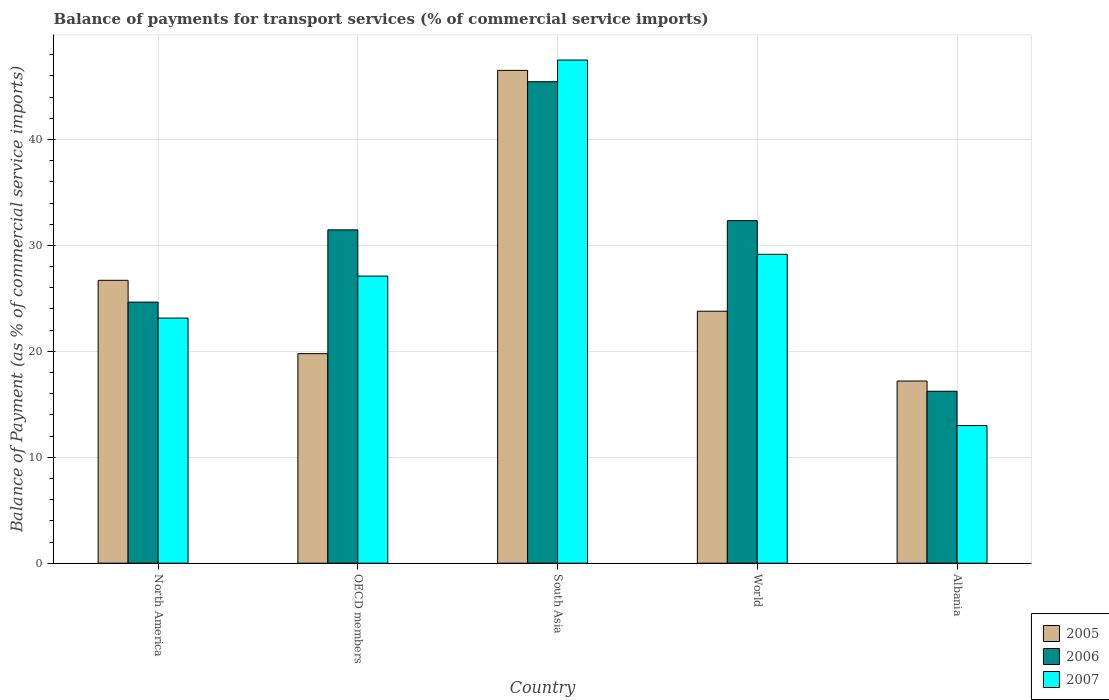How many different coloured bars are there?
Offer a terse response. 3. How many groups of bars are there?
Your response must be concise. 5. Are the number of bars per tick equal to the number of legend labels?
Make the answer very short. Yes. How many bars are there on the 1st tick from the left?
Keep it short and to the point. 3. In how many cases, is the number of bars for a given country not equal to the number of legend labels?
Your response must be concise. 0. What is the balance of payments for transport services in 2007 in OECD members?
Offer a very short reply. 27.11. Across all countries, what is the maximum balance of payments for transport services in 2007?
Your answer should be very brief. 47.5. Across all countries, what is the minimum balance of payments for transport services in 2006?
Provide a succinct answer. 16.23. In which country was the balance of payments for transport services in 2005 maximum?
Ensure brevity in your answer.  South Asia. In which country was the balance of payments for transport services in 2007 minimum?
Give a very brief answer. Albania. What is the total balance of payments for transport services in 2006 in the graph?
Give a very brief answer. 150.14. What is the difference between the balance of payments for transport services in 2007 in OECD members and that in South Asia?
Offer a very short reply. -20.39. What is the difference between the balance of payments for transport services in 2005 in OECD members and the balance of payments for transport services in 2007 in World?
Your answer should be compact. -9.38. What is the average balance of payments for transport services in 2007 per country?
Offer a very short reply. 27.98. What is the difference between the balance of payments for transport services of/in 2007 and balance of payments for transport services of/in 2005 in World?
Provide a short and direct response. 5.37. What is the ratio of the balance of payments for transport services in 2005 in Albania to that in North America?
Your answer should be compact. 0.64. Is the balance of payments for transport services in 2007 in OECD members less than that in South Asia?
Your response must be concise. Yes. Is the difference between the balance of payments for transport services in 2007 in North America and OECD members greater than the difference between the balance of payments for transport services in 2005 in North America and OECD members?
Make the answer very short. No. What is the difference between the highest and the second highest balance of payments for transport services in 2005?
Give a very brief answer. -19.82. What is the difference between the highest and the lowest balance of payments for transport services in 2005?
Offer a terse response. 29.33. In how many countries, is the balance of payments for transport services in 2005 greater than the average balance of payments for transport services in 2005 taken over all countries?
Offer a terse response. 1. What does the 1st bar from the right in OECD members represents?
Make the answer very short. 2007. Are all the bars in the graph horizontal?
Your answer should be very brief. No. What is the difference between two consecutive major ticks on the Y-axis?
Offer a very short reply. 10. Are the values on the major ticks of Y-axis written in scientific E-notation?
Keep it short and to the point. No. Does the graph contain any zero values?
Give a very brief answer. No. Where does the legend appear in the graph?
Make the answer very short. Bottom right. How are the legend labels stacked?
Your response must be concise. Vertical. What is the title of the graph?
Give a very brief answer. Balance of payments for transport services (% of commercial service imports). Does "1965" appear as one of the legend labels in the graph?
Provide a succinct answer. No. What is the label or title of the Y-axis?
Offer a very short reply. Balance of Payment (as % of commercial service imports). What is the Balance of Payment (as % of commercial service imports) of 2005 in North America?
Ensure brevity in your answer.  26.71. What is the Balance of Payment (as % of commercial service imports) in 2006 in North America?
Give a very brief answer. 24.65. What is the Balance of Payment (as % of commercial service imports) of 2007 in North America?
Your answer should be very brief. 23.14. What is the Balance of Payment (as % of commercial service imports) in 2005 in OECD members?
Provide a short and direct response. 19.78. What is the Balance of Payment (as % of commercial service imports) of 2006 in OECD members?
Offer a very short reply. 31.47. What is the Balance of Payment (as % of commercial service imports) in 2007 in OECD members?
Offer a very short reply. 27.11. What is the Balance of Payment (as % of commercial service imports) in 2005 in South Asia?
Keep it short and to the point. 46.53. What is the Balance of Payment (as % of commercial service imports) of 2006 in South Asia?
Offer a terse response. 45.46. What is the Balance of Payment (as % of commercial service imports) of 2007 in South Asia?
Offer a very short reply. 47.5. What is the Balance of Payment (as % of commercial service imports) in 2005 in World?
Make the answer very short. 23.79. What is the Balance of Payment (as % of commercial service imports) of 2006 in World?
Offer a terse response. 32.34. What is the Balance of Payment (as % of commercial service imports) in 2007 in World?
Give a very brief answer. 29.16. What is the Balance of Payment (as % of commercial service imports) in 2005 in Albania?
Offer a very short reply. 17.2. What is the Balance of Payment (as % of commercial service imports) of 2006 in Albania?
Your answer should be compact. 16.23. What is the Balance of Payment (as % of commercial service imports) in 2007 in Albania?
Your answer should be very brief. 12.99. Across all countries, what is the maximum Balance of Payment (as % of commercial service imports) in 2005?
Your answer should be compact. 46.53. Across all countries, what is the maximum Balance of Payment (as % of commercial service imports) in 2006?
Keep it short and to the point. 45.46. Across all countries, what is the maximum Balance of Payment (as % of commercial service imports) of 2007?
Give a very brief answer. 47.5. Across all countries, what is the minimum Balance of Payment (as % of commercial service imports) in 2005?
Provide a succinct answer. 17.2. Across all countries, what is the minimum Balance of Payment (as % of commercial service imports) in 2006?
Make the answer very short. 16.23. Across all countries, what is the minimum Balance of Payment (as % of commercial service imports) of 2007?
Your response must be concise. 12.99. What is the total Balance of Payment (as % of commercial service imports) in 2005 in the graph?
Provide a succinct answer. 134. What is the total Balance of Payment (as % of commercial service imports) of 2006 in the graph?
Provide a short and direct response. 150.14. What is the total Balance of Payment (as % of commercial service imports) of 2007 in the graph?
Your answer should be very brief. 139.9. What is the difference between the Balance of Payment (as % of commercial service imports) of 2005 in North America and that in OECD members?
Your answer should be very brief. 6.93. What is the difference between the Balance of Payment (as % of commercial service imports) of 2006 in North America and that in OECD members?
Offer a very short reply. -6.82. What is the difference between the Balance of Payment (as % of commercial service imports) of 2007 in North America and that in OECD members?
Ensure brevity in your answer.  -3.97. What is the difference between the Balance of Payment (as % of commercial service imports) of 2005 in North America and that in South Asia?
Make the answer very short. -19.82. What is the difference between the Balance of Payment (as % of commercial service imports) of 2006 in North America and that in South Asia?
Provide a succinct answer. -20.81. What is the difference between the Balance of Payment (as % of commercial service imports) in 2007 in North America and that in South Asia?
Give a very brief answer. -24.36. What is the difference between the Balance of Payment (as % of commercial service imports) of 2005 in North America and that in World?
Provide a short and direct response. 2.92. What is the difference between the Balance of Payment (as % of commercial service imports) of 2006 in North America and that in World?
Offer a terse response. -7.69. What is the difference between the Balance of Payment (as % of commercial service imports) in 2007 in North America and that in World?
Offer a terse response. -6.02. What is the difference between the Balance of Payment (as % of commercial service imports) in 2005 in North America and that in Albania?
Keep it short and to the point. 9.51. What is the difference between the Balance of Payment (as % of commercial service imports) in 2006 in North America and that in Albania?
Ensure brevity in your answer.  8.41. What is the difference between the Balance of Payment (as % of commercial service imports) in 2007 in North America and that in Albania?
Keep it short and to the point. 10.15. What is the difference between the Balance of Payment (as % of commercial service imports) in 2005 in OECD members and that in South Asia?
Provide a succinct answer. -26.74. What is the difference between the Balance of Payment (as % of commercial service imports) of 2006 in OECD members and that in South Asia?
Provide a succinct answer. -13.99. What is the difference between the Balance of Payment (as % of commercial service imports) in 2007 in OECD members and that in South Asia?
Ensure brevity in your answer.  -20.39. What is the difference between the Balance of Payment (as % of commercial service imports) of 2005 in OECD members and that in World?
Offer a very short reply. -4.01. What is the difference between the Balance of Payment (as % of commercial service imports) of 2006 in OECD members and that in World?
Ensure brevity in your answer.  -0.87. What is the difference between the Balance of Payment (as % of commercial service imports) of 2007 in OECD members and that in World?
Your response must be concise. -2.05. What is the difference between the Balance of Payment (as % of commercial service imports) of 2005 in OECD members and that in Albania?
Offer a very short reply. 2.58. What is the difference between the Balance of Payment (as % of commercial service imports) of 2006 in OECD members and that in Albania?
Provide a succinct answer. 15.24. What is the difference between the Balance of Payment (as % of commercial service imports) of 2007 in OECD members and that in Albania?
Your answer should be compact. 14.11. What is the difference between the Balance of Payment (as % of commercial service imports) of 2005 in South Asia and that in World?
Offer a very short reply. 22.74. What is the difference between the Balance of Payment (as % of commercial service imports) in 2006 in South Asia and that in World?
Keep it short and to the point. 13.12. What is the difference between the Balance of Payment (as % of commercial service imports) in 2007 in South Asia and that in World?
Your answer should be compact. 18.34. What is the difference between the Balance of Payment (as % of commercial service imports) of 2005 in South Asia and that in Albania?
Your answer should be very brief. 29.33. What is the difference between the Balance of Payment (as % of commercial service imports) of 2006 in South Asia and that in Albania?
Keep it short and to the point. 29.22. What is the difference between the Balance of Payment (as % of commercial service imports) of 2007 in South Asia and that in Albania?
Offer a very short reply. 34.51. What is the difference between the Balance of Payment (as % of commercial service imports) in 2005 in World and that in Albania?
Make the answer very short. 6.59. What is the difference between the Balance of Payment (as % of commercial service imports) of 2006 in World and that in Albania?
Your response must be concise. 16.11. What is the difference between the Balance of Payment (as % of commercial service imports) in 2007 in World and that in Albania?
Provide a short and direct response. 16.17. What is the difference between the Balance of Payment (as % of commercial service imports) in 2005 in North America and the Balance of Payment (as % of commercial service imports) in 2006 in OECD members?
Your answer should be compact. -4.76. What is the difference between the Balance of Payment (as % of commercial service imports) of 2005 in North America and the Balance of Payment (as % of commercial service imports) of 2007 in OECD members?
Your response must be concise. -0.4. What is the difference between the Balance of Payment (as % of commercial service imports) of 2006 in North America and the Balance of Payment (as % of commercial service imports) of 2007 in OECD members?
Your response must be concise. -2.46. What is the difference between the Balance of Payment (as % of commercial service imports) of 2005 in North America and the Balance of Payment (as % of commercial service imports) of 2006 in South Asia?
Offer a very short reply. -18.75. What is the difference between the Balance of Payment (as % of commercial service imports) of 2005 in North America and the Balance of Payment (as % of commercial service imports) of 2007 in South Asia?
Offer a terse response. -20.79. What is the difference between the Balance of Payment (as % of commercial service imports) in 2006 in North America and the Balance of Payment (as % of commercial service imports) in 2007 in South Asia?
Offer a terse response. -22.85. What is the difference between the Balance of Payment (as % of commercial service imports) in 2005 in North America and the Balance of Payment (as % of commercial service imports) in 2006 in World?
Keep it short and to the point. -5.63. What is the difference between the Balance of Payment (as % of commercial service imports) of 2005 in North America and the Balance of Payment (as % of commercial service imports) of 2007 in World?
Your response must be concise. -2.45. What is the difference between the Balance of Payment (as % of commercial service imports) in 2006 in North America and the Balance of Payment (as % of commercial service imports) in 2007 in World?
Offer a very short reply. -4.51. What is the difference between the Balance of Payment (as % of commercial service imports) in 2005 in North America and the Balance of Payment (as % of commercial service imports) in 2006 in Albania?
Provide a short and direct response. 10.48. What is the difference between the Balance of Payment (as % of commercial service imports) in 2005 in North America and the Balance of Payment (as % of commercial service imports) in 2007 in Albania?
Your answer should be compact. 13.71. What is the difference between the Balance of Payment (as % of commercial service imports) of 2006 in North America and the Balance of Payment (as % of commercial service imports) of 2007 in Albania?
Give a very brief answer. 11.65. What is the difference between the Balance of Payment (as % of commercial service imports) in 2005 in OECD members and the Balance of Payment (as % of commercial service imports) in 2006 in South Asia?
Make the answer very short. -25.67. What is the difference between the Balance of Payment (as % of commercial service imports) in 2005 in OECD members and the Balance of Payment (as % of commercial service imports) in 2007 in South Asia?
Ensure brevity in your answer.  -27.72. What is the difference between the Balance of Payment (as % of commercial service imports) of 2006 in OECD members and the Balance of Payment (as % of commercial service imports) of 2007 in South Asia?
Provide a succinct answer. -16.03. What is the difference between the Balance of Payment (as % of commercial service imports) in 2005 in OECD members and the Balance of Payment (as % of commercial service imports) in 2006 in World?
Your answer should be compact. -12.56. What is the difference between the Balance of Payment (as % of commercial service imports) in 2005 in OECD members and the Balance of Payment (as % of commercial service imports) in 2007 in World?
Give a very brief answer. -9.38. What is the difference between the Balance of Payment (as % of commercial service imports) of 2006 in OECD members and the Balance of Payment (as % of commercial service imports) of 2007 in World?
Keep it short and to the point. 2.31. What is the difference between the Balance of Payment (as % of commercial service imports) of 2005 in OECD members and the Balance of Payment (as % of commercial service imports) of 2006 in Albania?
Ensure brevity in your answer.  3.55. What is the difference between the Balance of Payment (as % of commercial service imports) in 2005 in OECD members and the Balance of Payment (as % of commercial service imports) in 2007 in Albania?
Ensure brevity in your answer.  6.79. What is the difference between the Balance of Payment (as % of commercial service imports) in 2006 in OECD members and the Balance of Payment (as % of commercial service imports) in 2007 in Albania?
Your answer should be compact. 18.48. What is the difference between the Balance of Payment (as % of commercial service imports) of 2005 in South Asia and the Balance of Payment (as % of commercial service imports) of 2006 in World?
Provide a succinct answer. 14.19. What is the difference between the Balance of Payment (as % of commercial service imports) in 2005 in South Asia and the Balance of Payment (as % of commercial service imports) in 2007 in World?
Your response must be concise. 17.36. What is the difference between the Balance of Payment (as % of commercial service imports) of 2006 in South Asia and the Balance of Payment (as % of commercial service imports) of 2007 in World?
Give a very brief answer. 16.29. What is the difference between the Balance of Payment (as % of commercial service imports) of 2005 in South Asia and the Balance of Payment (as % of commercial service imports) of 2006 in Albania?
Provide a succinct answer. 30.29. What is the difference between the Balance of Payment (as % of commercial service imports) in 2005 in South Asia and the Balance of Payment (as % of commercial service imports) in 2007 in Albania?
Keep it short and to the point. 33.53. What is the difference between the Balance of Payment (as % of commercial service imports) in 2006 in South Asia and the Balance of Payment (as % of commercial service imports) in 2007 in Albania?
Your answer should be compact. 32.46. What is the difference between the Balance of Payment (as % of commercial service imports) in 2005 in World and the Balance of Payment (as % of commercial service imports) in 2006 in Albania?
Your answer should be very brief. 7.56. What is the difference between the Balance of Payment (as % of commercial service imports) in 2005 in World and the Balance of Payment (as % of commercial service imports) in 2007 in Albania?
Offer a very short reply. 10.8. What is the difference between the Balance of Payment (as % of commercial service imports) of 2006 in World and the Balance of Payment (as % of commercial service imports) of 2007 in Albania?
Your answer should be compact. 19.35. What is the average Balance of Payment (as % of commercial service imports) of 2005 per country?
Offer a terse response. 26.8. What is the average Balance of Payment (as % of commercial service imports) of 2006 per country?
Provide a short and direct response. 30.03. What is the average Balance of Payment (as % of commercial service imports) in 2007 per country?
Your answer should be very brief. 27.98. What is the difference between the Balance of Payment (as % of commercial service imports) of 2005 and Balance of Payment (as % of commercial service imports) of 2006 in North America?
Provide a succinct answer. 2.06. What is the difference between the Balance of Payment (as % of commercial service imports) of 2005 and Balance of Payment (as % of commercial service imports) of 2007 in North America?
Offer a very short reply. 3.57. What is the difference between the Balance of Payment (as % of commercial service imports) in 2006 and Balance of Payment (as % of commercial service imports) in 2007 in North America?
Keep it short and to the point. 1.51. What is the difference between the Balance of Payment (as % of commercial service imports) of 2005 and Balance of Payment (as % of commercial service imports) of 2006 in OECD members?
Provide a short and direct response. -11.69. What is the difference between the Balance of Payment (as % of commercial service imports) of 2005 and Balance of Payment (as % of commercial service imports) of 2007 in OECD members?
Offer a very short reply. -7.33. What is the difference between the Balance of Payment (as % of commercial service imports) in 2006 and Balance of Payment (as % of commercial service imports) in 2007 in OECD members?
Provide a short and direct response. 4.36. What is the difference between the Balance of Payment (as % of commercial service imports) in 2005 and Balance of Payment (as % of commercial service imports) in 2006 in South Asia?
Your response must be concise. 1.07. What is the difference between the Balance of Payment (as % of commercial service imports) in 2005 and Balance of Payment (as % of commercial service imports) in 2007 in South Asia?
Keep it short and to the point. -0.98. What is the difference between the Balance of Payment (as % of commercial service imports) in 2006 and Balance of Payment (as % of commercial service imports) in 2007 in South Asia?
Your answer should be compact. -2.05. What is the difference between the Balance of Payment (as % of commercial service imports) in 2005 and Balance of Payment (as % of commercial service imports) in 2006 in World?
Offer a terse response. -8.55. What is the difference between the Balance of Payment (as % of commercial service imports) in 2005 and Balance of Payment (as % of commercial service imports) in 2007 in World?
Provide a short and direct response. -5.37. What is the difference between the Balance of Payment (as % of commercial service imports) in 2006 and Balance of Payment (as % of commercial service imports) in 2007 in World?
Give a very brief answer. 3.18. What is the difference between the Balance of Payment (as % of commercial service imports) of 2005 and Balance of Payment (as % of commercial service imports) of 2006 in Albania?
Your answer should be compact. 0.97. What is the difference between the Balance of Payment (as % of commercial service imports) of 2005 and Balance of Payment (as % of commercial service imports) of 2007 in Albania?
Offer a very short reply. 4.2. What is the difference between the Balance of Payment (as % of commercial service imports) of 2006 and Balance of Payment (as % of commercial service imports) of 2007 in Albania?
Offer a very short reply. 3.24. What is the ratio of the Balance of Payment (as % of commercial service imports) in 2005 in North America to that in OECD members?
Your answer should be very brief. 1.35. What is the ratio of the Balance of Payment (as % of commercial service imports) in 2006 in North America to that in OECD members?
Your response must be concise. 0.78. What is the ratio of the Balance of Payment (as % of commercial service imports) in 2007 in North America to that in OECD members?
Make the answer very short. 0.85. What is the ratio of the Balance of Payment (as % of commercial service imports) of 2005 in North America to that in South Asia?
Keep it short and to the point. 0.57. What is the ratio of the Balance of Payment (as % of commercial service imports) in 2006 in North America to that in South Asia?
Provide a succinct answer. 0.54. What is the ratio of the Balance of Payment (as % of commercial service imports) of 2007 in North America to that in South Asia?
Your response must be concise. 0.49. What is the ratio of the Balance of Payment (as % of commercial service imports) in 2005 in North America to that in World?
Make the answer very short. 1.12. What is the ratio of the Balance of Payment (as % of commercial service imports) in 2006 in North America to that in World?
Offer a very short reply. 0.76. What is the ratio of the Balance of Payment (as % of commercial service imports) in 2007 in North America to that in World?
Make the answer very short. 0.79. What is the ratio of the Balance of Payment (as % of commercial service imports) of 2005 in North America to that in Albania?
Provide a short and direct response. 1.55. What is the ratio of the Balance of Payment (as % of commercial service imports) of 2006 in North America to that in Albania?
Your answer should be very brief. 1.52. What is the ratio of the Balance of Payment (as % of commercial service imports) in 2007 in North America to that in Albania?
Provide a short and direct response. 1.78. What is the ratio of the Balance of Payment (as % of commercial service imports) in 2005 in OECD members to that in South Asia?
Make the answer very short. 0.43. What is the ratio of the Balance of Payment (as % of commercial service imports) in 2006 in OECD members to that in South Asia?
Provide a succinct answer. 0.69. What is the ratio of the Balance of Payment (as % of commercial service imports) in 2007 in OECD members to that in South Asia?
Give a very brief answer. 0.57. What is the ratio of the Balance of Payment (as % of commercial service imports) of 2005 in OECD members to that in World?
Offer a very short reply. 0.83. What is the ratio of the Balance of Payment (as % of commercial service imports) in 2006 in OECD members to that in World?
Your answer should be very brief. 0.97. What is the ratio of the Balance of Payment (as % of commercial service imports) of 2007 in OECD members to that in World?
Provide a succinct answer. 0.93. What is the ratio of the Balance of Payment (as % of commercial service imports) in 2005 in OECD members to that in Albania?
Provide a succinct answer. 1.15. What is the ratio of the Balance of Payment (as % of commercial service imports) in 2006 in OECD members to that in Albania?
Make the answer very short. 1.94. What is the ratio of the Balance of Payment (as % of commercial service imports) of 2007 in OECD members to that in Albania?
Give a very brief answer. 2.09. What is the ratio of the Balance of Payment (as % of commercial service imports) of 2005 in South Asia to that in World?
Ensure brevity in your answer.  1.96. What is the ratio of the Balance of Payment (as % of commercial service imports) in 2006 in South Asia to that in World?
Offer a very short reply. 1.41. What is the ratio of the Balance of Payment (as % of commercial service imports) in 2007 in South Asia to that in World?
Offer a terse response. 1.63. What is the ratio of the Balance of Payment (as % of commercial service imports) of 2005 in South Asia to that in Albania?
Provide a succinct answer. 2.71. What is the ratio of the Balance of Payment (as % of commercial service imports) in 2006 in South Asia to that in Albania?
Your response must be concise. 2.8. What is the ratio of the Balance of Payment (as % of commercial service imports) in 2007 in South Asia to that in Albania?
Your response must be concise. 3.66. What is the ratio of the Balance of Payment (as % of commercial service imports) in 2005 in World to that in Albania?
Your response must be concise. 1.38. What is the ratio of the Balance of Payment (as % of commercial service imports) of 2006 in World to that in Albania?
Your answer should be compact. 1.99. What is the ratio of the Balance of Payment (as % of commercial service imports) of 2007 in World to that in Albania?
Provide a succinct answer. 2.24. What is the difference between the highest and the second highest Balance of Payment (as % of commercial service imports) in 2005?
Your response must be concise. 19.82. What is the difference between the highest and the second highest Balance of Payment (as % of commercial service imports) in 2006?
Give a very brief answer. 13.12. What is the difference between the highest and the second highest Balance of Payment (as % of commercial service imports) of 2007?
Offer a very short reply. 18.34. What is the difference between the highest and the lowest Balance of Payment (as % of commercial service imports) in 2005?
Your answer should be very brief. 29.33. What is the difference between the highest and the lowest Balance of Payment (as % of commercial service imports) in 2006?
Offer a terse response. 29.22. What is the difference between the highest and the lowest Balance of Payment (as % of commercial service imports) of 2007?
Your answer should be very brief. 34.51. 